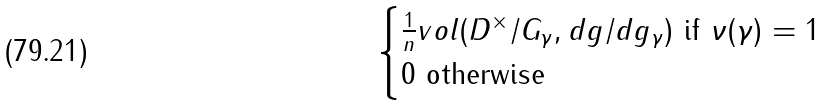<formula> <loc_0><loc_0><loc_500><loc_500>\begin{cases} \frac { 1 } { n } v o l ( D ^ { \times } / G _ { \gamma } , d g / d g _ { \gamma } ) \text { if } \nu ( \gamma ) = 1 \\ 0 \text {        otherwise } \end{cases}</formula> 